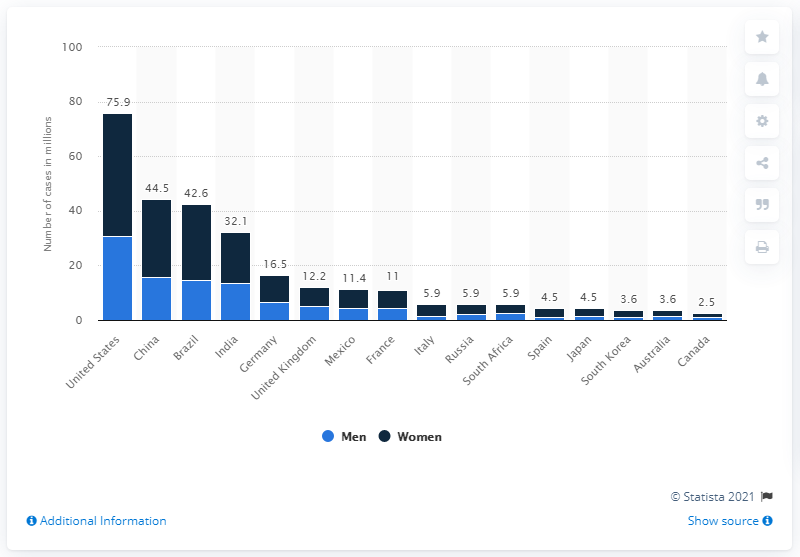Outline some significant characteristics in this image. In 2018, it is estimated that approximately 30.7% of men in the United States experienced an anxiety disorder. 